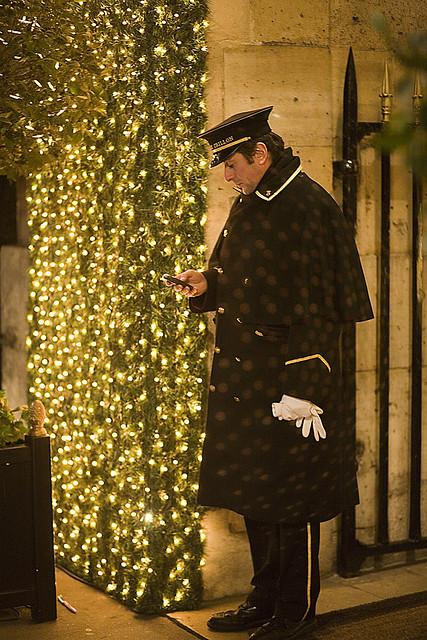What is this man looking at?
Give a very brief answer. Phone. Are those Christmas lights?
Give a very brief answer. Yes. Why did the man take off one glove?
Short answer required. Use phone. 